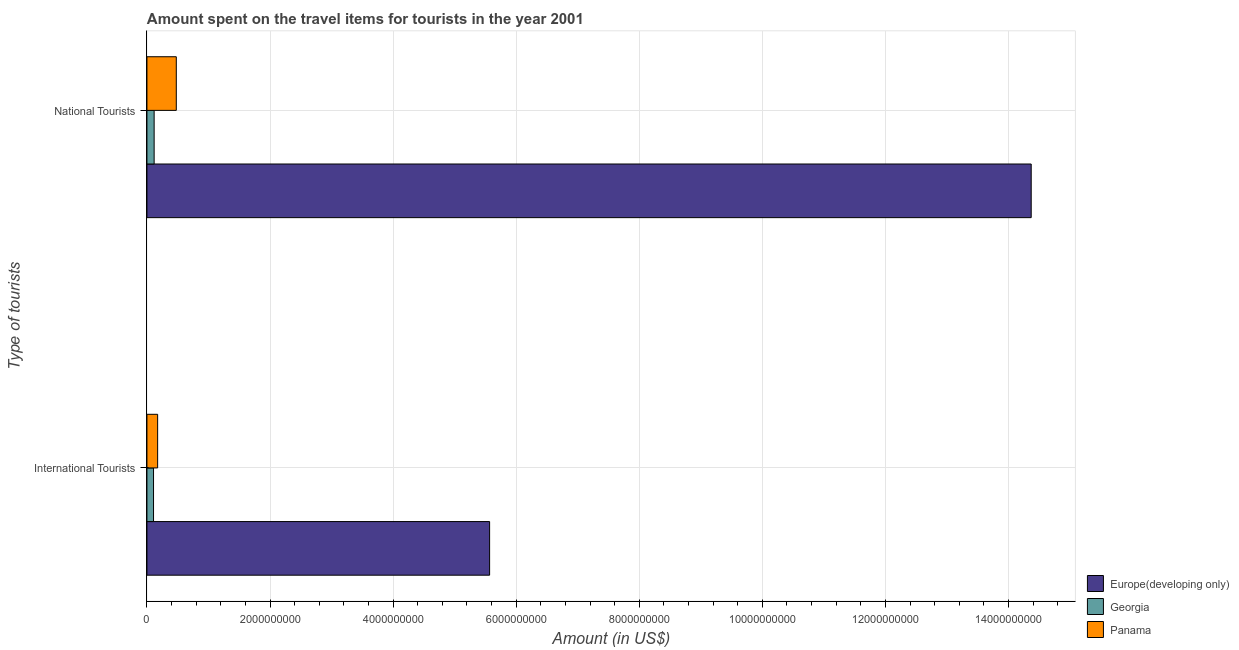How many different coloured bars are there?
Provide a succinct answer. 3. How many groups of bars are there?
Provide a short and direct response. 2. What is the label of the 2nd group of bars from the top?
Offer a terse response. International Tourists. What is the amount spent on travel items of international tourists in Georgia?
Offer a terse response. 1.07e+08. Across all countries, what is the maximum amount spent on travel items of national tourists?
Give a very brief answer. 1.44e+1. Across all countries, what is the minimum amount spent on travel items of international tourists?
Ensure brevity in your answer.  1.07e+08. In which country was the amount spent on travel items of national tourists maximum?
Offer a terse response. Europe(developing only). In which country was the amount spent on travel items of national tourists minimum?
Your answer should be very brief. Georgia. What is the total amount spent on travel items of national tourists in the graph?
Your answer should be very brief. 1.50e+1. What is the difference between the amount spent on travel items of international tourists in Europe(developing only) and that in Georgia?
Offer a terse response. 5.46e+09. What is the difference between the amount spent on travel items of international tourists in Panama and the amount spent on travel items of national tourists in Georgia?
Provide a succinct answer. 5.70e+07. What is the average amount spent on travel items of national tourists per country?
Make the answer very short. 4.99e+09. What is the difference between the amount spent on travel items of national tourists and amount spent on travel items of international tourists in Panama?
Provide a succinct answer. 3.03e+08. In how many countries, is the amount spent on travel items of national tourists greater than 5200000000 US$?
Offer a terse response. 1. What is the ratio of the amount spent on travel items of national tourists in Europe(developing only) to that in Panama?
Ensure brevity in your answer.  30.12. Is the amount spent on travel items of international tourists in Georgia less than that in Panama?
Your answer should be compact. Yes. In how many countries, is the amount spent on travel items of national tourists greater than the average amount spent on travel items of national tourists taken over all countries?
Keep it short and to the point. 1. What does the 3rd bar from the top in International Tourists represents?
Provide a succinct answer. Europe(developing only). What does the 3rd bar from the bottom in National Tourists represents?
Offer a terse response. Panama. Are all the bars in the graph horizontal?
Your answer should be very brief. Yes. What is the difference between two consecutive major ticks on the X-axis?
Your response must be concise. 2.00e+09. Are the values on the major ticks of X-axis written in scientific E-notation?
Provide a succinct answer. No. Does the graph contain any zero values?
Offer a terse response. No. Does the graph contain grids?
Make the answer very short. Yes. Where does the legend appear in the graph?
Make the answer very short. Bottom right. How many legend labels are there?
Make the answer very short. 3. What is the title of the graph?
Ensure brevity in your answer.  Amount spent on the travel items for tourists in the year 2001. Does "Liechtenstein" appear as one of the legend labels in the graph?
Ensure brevity in your answer.  No. What is the label or title of the X-axis?
Your answer should be very brief. Amount (in US$). What is the label or title of the Y-axis?
Give a very brief answer. Type of tourists. What is the Amount (in US$) in Europe(developing only) in International Tourists?
Your response must be concise. 5.57e+09. What is the Amount (in US$) in Georgia in International Tourists?
Give a very brief answer. 1.07e+08. What is the Amount (in US$) of Panama in International Tourists?
Give a very brief answer. 1.74e+08. What is the Amount (in US$) of Europe(developing only) in National Tourists?
Your response must be concise. 1.44e+1. What is the Amount (in US$) of Georgia in National Tourists?
Make the answer very short. 1.17e+08. What is the Amount (in US$) in Panama in National Tourists?
Provide a succinct answer. 4.77e+08. Across all Type of tourists, what is the maximum Amount (in US$) in Europe(developing only)?
Your answer should be compact. 1.44e+1. Across all Type of tourists, what is the maximum Amount (in US$) of Georgia?
Provide a short and direct response. 1.17e+08. Across all Type of tourists, what is the maximum Amount (in US$) in Panama?
Your answer should be very brief. 4.77e+08. Across all Type of tourists, what is the minimum Amount (in US$) of Europe(developing only)?
Offer a terse response. 5.57e+09. Across all Type of tourists, what is the minimum Amount (in US$) in Georgia?
Your answer should be compact. 1.07e+08. Across all Type of tourists, what is the minimum Amount (in US$) in Panama?
Provide a short and direct response. 1.74e+08. What is the total Amount (in US$) in Europe(developing only) in the graph?
Make the answer very short. 1.99e+1. What is the total Amount (in US$) in Georgia in the graph?
Your response must be concise. 2.24e+08. What is the total Amount (in US$) of Panama in the graph?
Provide a succinct answer. 6.51e+08. What is the difference between the Amount (in US$) in Europe(developing only) in International Tourists and that in National Tourists?
Your answer should be very brief. -8.80e+09. What is the difference between the Amount (in US$) in Georgia in International Tourists and that in National Tourists?
Give a very brief answer. -1.00e+07. What is the difference between the Amount (in US$) in Panama in International Tourists and that in National Tourists?
Offer a very short reply. -3.03e+08. What is the difference between the Amount (in US$) of Europe(developing only) in International Tourists and the Amount (in US$) of Georgia in National Tourists?
Provide a short and direct response. 5.45e+09. What is the difference between the Amount (in US$) of Europe(developing only) in International Tourists and the Amount (in US$) of Panama in National Tourists?
Give a very brief answer. 5.09e+09. What is the difference between the Amount (in US$) in Georgia in International Tourists and the Amount (in US$) in Panama in National Tourists?
Offer a terse response. -3.70e+08. What is the average Amount (in US$) of Europe(developing only) per Type of tourists?
Offer a terse response. 9.97e+09. What is the average Amount (in US$) in Georgia per Type of tourists?
Provide a succinct answer. 1.12e+08. What is the average Amount (in US$) of Panama per Type of tourists?
Make the answer very short. 3.26e+08. What is the difference between the Amount (in US$) of Europe(developing only) and Amount (in US$) of Georgia in International Tourists?
Keep it short and to the point. 5.46e+09. What is the difference between the Amount (in US$) in Europe(developing only) and Amount (in US$) in Panama in International Tourists?
Offer a terse response. 5.39e+09. What is the difference between the Amount (in US$) in Georgia and Amount (in US$) in Panama in International Tourists?
Your answer should be compact. -6.70e+07. What is the difference between the Amount (in US$) of Europe(developing only) and Amount (in US$) of Georgia in National Tourists?
Provide a short and direct response. 1.43e+1. What is the difference between the Amount (in US$) in Europe(developing only) and Amount (in US$) in Panama in National Tourists?
Your answer should be very brief. 1.39e+1. What is the difference between the Amount (in US$) of Georgia and Amount (in US$) of Panama in National Tourists?
Your answer should be compact. -3.60e+08. What is the ratio of the Amount (in US$) in Europe(developing only) in International Tourists to that in National Tourists?
Keep it short and to the point. 0.39. What is the ratio of the Amount (in US$) in Georgia in International Tourists to that in National Tourists?
Provide a succinct answer. 0.91. What is the ratio of the Amount (in US$) of Panama in International Tourists to that in National Tourists?
Your answer should be very brief. 0.36. What is the difference between the highest and the second highest Amount (in US$) of Europe(developing only)?
Provide a short and direct response. 8.80e+09. What is the difference between the highest and the second highest Amount (in US$) of Georgia?
Your answer should be compact. 1.00e+07. What is the difference between the highest and the second highest Amount (in US$) in Panama?
Offer a very short reply. 3.03e+08. What is the difference between the highest and the lowest Amount (in US$) of Europe(developing only)?
Your answer should be very brief. 8.80e+09. What is the difference between the highest and the lowest Amount (in US$) in Georgia?
Give a very brief answer. 1.00e+07. What is the difference between the highest and the lowest Amount (in US$) of Panama?
Offer a terse response. 3.03e+08. 